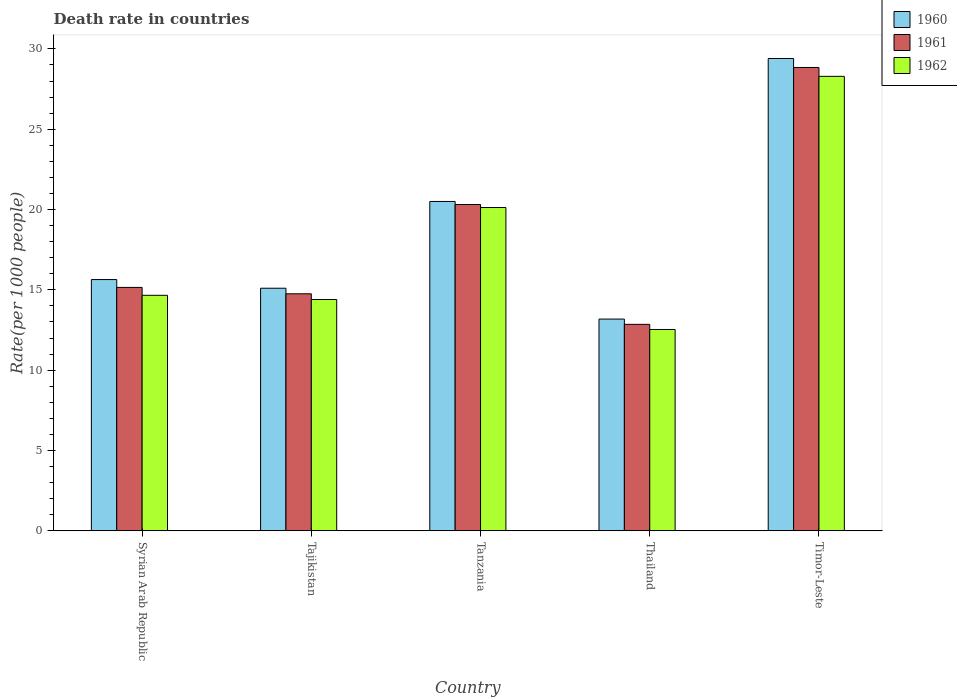How many groups of bars are there?
Provide a succinct answer. 5. Are the number of bars per tick equal to the number of legend labels?
Ensure brevity in your answer.  Yes. Are the number of bars on each tick of the X-axis equal?
Make the answer very short. Yes. How many bars are there on the 5th tick from the left?
Make the answer very short. 3. What is the label of the 2nd group of bars from the left?
Give a very brief answer. Tajikistan. In how many cases, is the number of bars for a given country not equal to the number of legend labels?
Keep it short and to the point. 0. What is the death rate in 1961 in Thailand?
Ensure brevity in your answer.  12.85. Across all countries, what is the maximum death rate in 1962?
Keep it short and to the point. 28.29. Across all countries, what is the minimum death rate in 1960?
Give a very brief answer. 13.18. In which country was the death rate in 1961 maximum?
Provide a short and direct response. Timor-Leste. In which country was the death rate in 1961 minimum?
Offer a very short reply. Thailand. What is the total death rate in 1961 in the graph?
Give a very brief answer. 91.91. What is the difference between the death rate in 1960 in Thailand and that in Timor-Leste?
Your answer should be compact. -16.22. What is the difference between the death rate in 1960 in Syrian Arab Republic and the death rate in 1962 in Thailand?
Provide a succinct answer. 3.11. What is the average death rate in 1961 per country?
Provide a succinct answer. 18.38. What is the difference between the death rate of/in 1962 and death rate of/in 1960 in Tanzania?
Provide a short and direct response. -0.38. In how many countries, is the death rate in 1962 greater than 15?
Ensure brevity in your answer.  2. What is the ratio of the death rate in 1962 in Tajikistan to that in Thailand?
Provide a short and direct response. 1.15. Is the death rate in 1961 in Tajikistan less than that in Timor-Leste?
Make the answer very short. Yes. What is the difference between the highest and the second highest death rate in 1962?
Give a very brief answer. 8.17. What is the difference between the highest and the lowest death rate in 1962?
Provide a short and direct response. 15.76. In how many countries, is the death rate in 1962 greater than the average death rate in 1962 taken over all countries?
Ensure brevity in your answer.  2. Is the sum of the death rate in 1960 in Syrian Arab Republic and Tanzania greater than the maximum death rate in 1962 across all countries?
Your answer should be compact. Yes. What does the 2nd bar from the left in Thailand represents?
Provide a short and direct response. 1961. What does the 3rd bar from the right in Tanzania represents?
Ensure brevity in your answer.  1960. Is it the case that in every country, the sum of the death rate in 1961 and death rate in 1962 is greater than the death rate in 1960?
Provide a succinct answer. Yes. Are all the bars in the graph horizontal?
Your answer should be compact. No. Are the values on the major ticks of Y-axis written in scientific E-notation?
Ensure brevity in your answer.  No. Does the graph contain grids?
Offer a terse response. No. How are the legend labels stacked?
Keep it short and to the point. Vertical. What is the title of the graph?
Keep it short and to the point. Death rate in countries. Does "1975" appear as one of the legend labels in the graph?
Your answer should be very brief. No. What is the label or title of the Y-axis?
Keep it short and to the point. Rate(per 1000 people). What is the Rate(per 1000 people) of 1960 in Syrian Arab Republic?
Make the answer very short. 15.64. What is the Rate(per 1000 people) of 1961 in Syrian Arab Republic?
Your answer should be compact. 15.15. What is the Rate(per 1000 people) of 1962 in Syrian Arab Republic?
Your response must be concise. 14.66. What is the Rate(per 1000 people) of 1960 in Tajikistan?
Provide a short and direct response. 15.1. What is the Rate(per 1000 people) in 1961 in Tajikistan?
Provide a short and direct response. 14.75. What is the Rate(per 1000 people) in 1962 in Tajikistan?
Your answer should be compact. 14.4. What is the Rate(per 1000 people) in 1960 in Tanzania?
Make the answer very short. 20.5. What is the Rate(per 1000 people) of 1961 in Tanzania?
Keep it short and to the point. 20.31. What is the Rate(per 1000 people) of 1962 in Tanzania?
Offer a very short reply. 20.12. What is the Rate(per 1000 people) of 1960 in Thailand?
Offer a terse response. 13.18. What is the Rate(per 1000 people) of 1961 in Thailand?
Give a very brief answer. 12.85. What is the Rate(per 1000 people) in 1962 in Thailand?
Provide a succinct answer. 12.53. What is the Rate(per 1000 people) in 1960 in Timor-Leste?
Your answer should be very brief. 29.4. What is the Rate(per 1000 people) in 1961 in Timor-Leste?
Make the answer very short. 28.84. What is the Rate(per 1000 people) in 1962 in Timor-Leste?
Your answer should be compact. 28.29. Across all countries, what is the maximum Rate(per 1000 people) in 1960?
Ensure brevity in your answer.  29.4. Across all countries, what is the maximum Rate(per 1000 people) of 1961?
Provide a short and direct response. 28.84. Across all countries, what is the maximum Rate(per 1000 people) of 1962?
Provide a succinct answer. 28.29. Across all countries, what is the minimum Rate(per 1000 people) of 1960?
Your answer should be compact. 13.18. Across all countries, what is the minimum Rate(per 1000 people) of 1961?
Make the answer very short. 12.85. Across all countries, what is the minimum Rate(per 1000 people) of 1962?
Your answer should be very brief. 12.53. What is the total Rate(per 1000 people) of 1960 in the graph?
Your answer should be compact. 93.83. What is the total Rate(per 1000 people) of 1961 in the graph?
Give a very brief answer. 91.91. What is the total Rate(per 1000 people) in 1962 in the graph?
Provide a short and direct response. 90.01. What is the difference between the Rate(per 1000 people) in 1960 in Syrian Arab Republic and that in Tajikistan?
Your response must be concise. 0.54. What is the difference between the Rate(per 1000 people) of 1961 in Syrian Arab Republic and that in Tajikistan?
Offer a terse response. 0.4. What is the difference between the Rate(per 1000 people) of 1962 in Syrian Arab Republic and that in Tajikistan?
Your answer should be very brief. 0.26. What is the difference between the Rate(per 1000 people) in 1960 in Syrian Arab Republic and that in Tanzania?
Give a very brief answer. -4.86. What is the difference between the Rate(per 1000 people) in 1961 in Syrian Arab Republic and that in Tanzania?
Offer a terse response. -5.16. What is the difference between the Rate(per 1000 people) in 1962 in Syrian Arab Republic and that in Tanzania?
Your answer should be compact. -5.46. What is the difference between the Rate(per 1000 people) in 1960 in Syrian Arab Republic and that in Thailand?
Make the answer very short. 2.46. What is the difference between the Rate(per 1000 people) in 1961 in Syrian Arab Republic and that in Thailand?
Make the answer very short. 2.3. What is the difference between the Rate(per 1000 people) of 1962 in Syrian Arab Republic and that in Thailand?
Give a very brief answer. 2.13. What is the difference between the Rate(per 1000 people) of 1960 in Syrian Arab Republic and that in Timor-Leste?
Offer a very short reply. -13.76. What is the difference between the Rate(per 1000 people) of 1961 in Syrian Arab Republic and that in Timor-Leste?
Provide a succinct answer. -13.69. What is the difference between the Rate(per 1000 people) in 1962 in Syrian Arab Republic and that in Timor-Leste?
Provide a short and direct response. -13.63. What is the difference between the Rate(per 1000 people) of 1960 in Tajikistan and that in Tanzania?
Make the answer very short. -5.4. What is the difference between the Rate(per 1000 people) in 1961 in Tajikistan and that in Tanzania?
Your response must be concise. -5.56. What is the difference between the Rate(per 1000 people) in 1962 in Tajikistan and that in Tanzania?
Ensure brevity in your answer.  -5.73. What is the difference between the Rate(per 1000 people) in 1960 in Tajikistan and that in Thailand?
Provide a short and direct response. 1.92. What is the difference between the Rate(per 1000 people) of 1961 in Tajikistan and that in Thailand?
Give a very brief answer. 1.9. What is the difference between the Rate(per 1000 people) in 1962 in Tajikistan and that in Thailand?
Provide a short and direct response. 1.87. What is the difference between the Rate(per 1000 people) in 1960 in Tajikistan and that in Timor-Leste?
Offer a very short reply. -14.3. What is the difference between the Rate(per 1000 people) in 1961 in Tajikistan and that in Timor-Leste?
Make the answer very short. -14.09. What is the difference between the Rate(per 1000 people) in 1962 in Tajikistan and that in Timor-Leste?
Keep it short and to the point. -13.89. What is the difference between the Rate(per 1000 people) in 1960 in Tanzania and that in Thailand?
Offer a very short reply. 7.32. What is the difference between the Rate(per 1000 people) of 1961 in Tanzania and that in Thailand?
Your answer should be very brief. 7.46. What is the difference between the Rate(per 1000 people) of 1962 in Tanzania and that in Thailand?
Keep it short and to the point. 7.59. What is the difference between the Rate(per 1000 people) in 1960 in Tanzania and that in Timor-Leste?
Give a very brief answer. -8.9. What is the difference between the Rate(per 1000 people) of 1961 in Tanzania and that in Timor-Leste?
Your answer should be compact. -8.53. What is the difference between the Rate(per 1000 people) of 1962 in Tanzania and that in Timor-Leste?
Ensure brevity in your answer.  -8.17. What is the difference between the Rate(per 1000 people) of 1960 in Thailand and that in Timor-Leste?
Your answer should be very brief. -16.22. What is the difference between the Rate(per 1000 people) in 1961 in Thailand and that in Timor-Leste?
Offer a very short reply. -15.99. What is the difference between the Rate(per 1000 people) in 1962 in Thailand and that in Timor-Leste?
Make the answer very short. -15.76. What is the difference between the Rate(per 1000 people) of 1960 in Syrian Arab Republic and the Rate(per 1000 people) of 1961 in Tajikistan?
Provide a succinct answer. 0.89. What is the difference between the Rate(per 1000 people) of 1960 in Syrian Arab Republic and the Rate(per 1000 people) of 1962 in Tajikistan?
Make the answer very short. 1.24. What is the difference between the Rate(per 1000 people) in 1961 in Syrian Arab Republic and the Rate(per 1000 people) in 1962 in Tajikistan?
Offer a very short reply. 0.75. What is the difference between the Rate(per 1000 people) in 1960 in Syrian Arab Republic and the Rate(per 1000 people) in 1961 in Tanzania?
Make the answer very short. -4.67. What is the difference between the Rate(per 1000 people) in 1960 in Syrian Arab Republic and the Rate(per 1000 people) in 1962 in Tanzania?
Your answer should be compact. -4.48. What is the difference between the Rate(per 1000 people) of 1961 in Syrian Arab Republic and the Rate(per 1000 people) of 1962 in Tanzania?
Keep it short and to the point. -4.97. What is the difference between the Rate(per 1000 people) of 1960 in Syrian Arab Republic and the Rate(per 1000 people) of 1961 in Thailand?
Ensure brevity in your answer.  2.79. What is the difference between the Rate(per 1000 people) of 1960 in Syrian Arab Republic and the Rate(per 1000 people) of 1962 in Thailand?
Provide a short and direct response. 3.11. What is the difference between the Rate(per 1000 people) in 1961 in Syrian Arab Republic and the Rate(per 1000 people) in 1962 in Thailand?
Your response must be concise. 2.62. What is the difference between the Rate(per 1000 people) of 1960 in Syrian Arab Republic and the Rate(per 1000 people) of 1961 in Timor-Leste?
Keep it short and to the point. -13.2. What is the difference between the Rate(per 1000 people) in 1960 in Syrian Arab Republic and the Rate(per 1000 people) in 1962 in Timor-Leste?
Give a very brief answer. -12.65. What is the difference between the Rate(per 1000 people) of 1961 in Syrian Arab Republic and the Rate(per 1000 people) of 1962 in Timor-Leste?
Offer a terse response. -13.14. What is the difference between the Rate(per 1000 people) of 1960 in Tajikistan and the Rate(per 1000 people) of 1961 in Tanzania?
Provide a short and direct response. -5.21. What is the difference between the Rate(per 1000 people) of 1960 in Tajikistan and the Rate(per 1000 people) of 1962 in Tanzania?
Provide a short and direct response. -5.02. What is the difference between the Rate(per 1000 people) in 1961 in Tajikistan and the Rate(per 1000 people) in 1962 in Tanzania?
Your answer should be very brief. -5.37. What is the difference between the Rate(per 1000 people) in 1960 in Tajikistan and the Rate(per 1000 people) in 1961 in Thailand?
Provide a succinct answer. 2.25. What is the difference between the Rate(per 1000 people) in 1960 in Tajikistan and the Rate(per 1000 people) in 1962 in Thailand?
Give a very brief answer. 2.57. What is the difference between the Rate(per 1000 people) of 1961 in Tajikistan and the Rate(per 1000 people) of 1962 in Thailand?
Your answer should be compact. 2.22. What is the difference between the Rate(per 1000 people) of 1960 in Tajikistan and the Rate(per 1000 people) of 1961 in Timor-Leste?
Provide a succinct answer. -13.74. What is the difference between the Rate(per 1000 people) of 1960 in Tajikistan and the Rate(per 1000 people) of 1962 in Timor-Leste?
Keep it short and to the point. -13.19. What is the difference between the Rate(per 1000 people) of 1961 in Tajikistan and the Rate(per 1000 people) of 1962 in Timor-Leste?
Ensure brevity in your answer.  -13.54. What is the difference between the Rate(per 1000 people) of 1960 in Tanzania and the Rate(per 1000 people) of 1961 in Thailand?
Offer a very short reply. 7.65. What is the difference between the Rate(per 1000 people) in 1960 in Tanzania and the Rate(per 1000 people) in 1962 in Thailand?
Offer a terse response. 7.97. What is the difference between the Rate(per 1000 people) in 1961 in Tanzania and the Rate(per 1000 people) in 1962 in Thailand?
Give a very brief answer. 7.78. What is the difference between the Rate(per 1000 people) in 1960 in Tanzania and the Rate(per 1000 people) in 1961 in Timor-Leste?
Your answer should be very brief. -8.34. What is the difference between the Rate(per 1000 people) in 1960 in Tanzania and the Rate(per 1000 people) in 1962 in Timor-Leste?
Offer a terse response. -7.79. What is the difference between the Rate(per 1000 people) in 1961 in Tanzania and the Rate(per 1000 people) in 1962 in Timor-Leste?
Your answer should be very brief. -7.98. What is the difference between the Rate(per 1000 people) in 1960 in Thailand and the Rate(per 1000 people) in 1961 in Timor-Leste?
Your response must be concise. -15.66. What is the difference between the Rate(per 1000 people) of 1960 in Thailand and the Rate(per 1000 people) of 1962 in Timor-Leste?
Provide a short and direct response. -15.11. What is the difference between the Rate(per 1000 people) in 1961 in Thailand and the Rate(per 1000 people) in 1962 in Timor-Leste?
Your response must be concise. -15.44. What is the average Rate(per 1000 people) of 1960 per country?
Ensure brevity in your answer.  18.77. What is the average Rate(per 1000 people) of 1961 per country?
Ensure brevity in your answer.  18.38. What is the average Rate(per 1000 people) of 1962 per country?
Offer a terse response. 18. What is the difference between the Rate(per 1000 people) of 1960 and Rate(per 1000 people) of 1961 in Syrian Arab Republic?
Provide a short and direct response. 0.49. What is the difference between the Rate(per 1000 people) of 1961 and Rate(per 1000 people) of 1962 in Syrian Arab Republic?
Make the answer very short. 0.49. What is the difference between the Rate(per 1000 people) in 1960 and Rate(per 1000 people) in 1961 in Tajikistan?
Keep it short and to the point. 0.35. What is the difference between the Rate(per 1000 people) of 1960 and Rate(per 1000 people) of 1962 in Tajikistan?
Offer a terse response. 0.7. What is the difference between the Rate(per 1000 people) in 1961 and Rate(per 1000 people) in 1962 in Tajikistan?
Give a very brief answer. 0.35. What is the difference between the Rate(per 1000 people) of 1960 and Rate(per 1000 people) of 1961 in Tanzania?
Make the answer very short. 0.19. What is the difference between the Rate(per 1000 people) of 1960 and Rate(per 1000 people) of 1962 in Tanzania?
Make the answer very short. 0.38. What is the difference between the Rate(per 1000 people) of 1961 and Rate(per 1000 people) of 1962 in Tanzania?
Provide a short and direct response. 0.19. What is the difference between the Rate(per 1000 people) in 1960 and Rate(per 1000 people) in 1961 in Thailand?
Provide a succinct answer. 0.33. What is the difference between the Rate(per 1000 people) of 1960 and Rate(per 1000 people) of 1962 in Thailand?
Provide a succinct answer. 0.65. What is the difference between the Rate(per 1000 people) of 1961 and Rate(per 1000 people) of 1962 in Thailand?
Provide a short and direct response. 0.32. What is the difference between the Rate(per 1000 people) in 1960 and Rate(per 1000 people) in 1961 in Timor-Leste?
Make the answer very short. 0.56. What is the difference between the Rate(per 1000 people) in 1960 and Rate(per 1000 people) in 1962 in Timor-Leste?
Give a very brief answer. 1.11. What is the difference between the Rate(per 1000 people) in 1961 and Rate(per 1000 people) in 1962 in Timor-Leste?
Offer a very short reply. 0.55. What is the ratio of the Rate(per 1000 people) in 1960 in Syrian Arab Republic to that in Tajikistan?
Make the answer very short. 1.04. What is the ratio of the Rate(per 1000 people) of 1961 in Syrian Arab Republic to that in Tajikistan?
Make the answer very short. 1.03. What is the ratio of the Rate(per 1000 people) in 1962 in Syrian Arab Republic to that in Tajikistan?
Ensure brevity in your answer.  1.02. What is the ratio of the Rate(per 1000 people) in 1960 in Syrian Arab Republic to that in Tanzania?
Your answer should be very brief. 0.76. What is the ratio of the Rate(per 1000 people) in 1961 in Syrian Arab Republic to that in Tanzania?
Offer a very short reply. 0.75. What is the ratio of the Rate(per 1000 people) in 1962 in Syrian Arab Republic to that in Tanzania?
Your response must be concise. 0.73. What is the ratio of the Rate(per 1000 people) in 1960 in Syrian Arab Republic to that in Thailand?
Make the answer very short. 1.19. What is the ratio of the Rate(per 1000 people) in 1961 in Syrian Arab Republic to that in Thailand?
Provide a succinct answer. 1.18. What is the ratio of the Rate(per 1000 people) in 1962 in Syrian Arab Republic to that in Thailand?
Your answer should be very brief. 1.17. What is the ratio of the Rate(per 1000 people) in 1960 in Syrian Arab Republic to that in Timor-Leste?
Keep it short and to the point. 0.53. What is the ratio of the Rate(per 1000 people) of 1961 in Syrian Arab Republic to that in Timor-Leste?
Provide a succinct answer. 0.53. What is the ratio of the Rate(per 1000 people) of 1962 in Syrian Arab Republic to that in Timor-Leste?
Your answer should be very brief. 0.52. What is the ratio of the Rate(per 1000 people) of 1960 in Tajikistan to that in Tanzania?
Provide a short and direct response. 0.74. What is the ratio of the Rate(per 1000 people) of 1961 in Tajikistan to that in Tanzania?
Your answer should be compact. 0.73. What is the ratio of the Rate(per 1000 people) in 1962 in Tajikistan to that in Tanzania?
Offer a very short reply. 0.72. What is the ratio of the Rate(per 1000 people) of 1960 in Tajikistan to that in Thailand?
Your answer should be very brief. 1.15. What is the ratio of the Rate(per 1000 people) of 1961 in Tajikistan to that in Thailand?
Offer a very short reply. 1.15. What is the ratio of the Rate(per 1000 people) of 1962 in Tajikistan to that in Thailand?
Keep it short and to the point. 1.15. What is the ratio of the Rate(per 1000 people) in 1960 in Tajikistan to that in Timor-Leste?
Keep it short and to the point. 0.51. What is the ratio of the Rate(per 1000 people) of 1961 in Tajikistan to that in Timor-Leste?
Offer a terse response. 0.51. What is the ratio of the Rate(per 1000 people) of 1962 in Tajikistan to that in Timor-Leste?
Your answer should be compact. 0.51. What is the ratio of the Rate(per 1000 people) in 1960 in Tanzania to that in Thailand?
Provide a succinct answer. 1.56. What is the ratio of the Rate(per 1000 people) in 1961 in Tanzania to that in Thailand?
Offer a terse response. 1.58. What is the ratio of the Rate(per 1000 people) of 1962 in Tanzania to that in Thailand?
Your answer should be compact. 1.61. What is the ratio of the Rate(per 1000 people) in 1960 in Tanzania to that in Timor-Leste?
Offer a terse response. 0.7. What is the ratio of the Rate(per 1000 people) of 1961 in Tanzania to that in Timor-Leste?
Make the answer very short. 0.7. What is the ratio of the Rate(per 1000 people) in 1962 in Tanzania to that in Timor-Leste?
Your response must be concise. 0.71. What is the ratio of the Rate(per 1000 people) of 1960 in Thailand to that in Timor-Leste?
Your answer should be compact. 0.45. What is the ratio of the Rate(per 1000 people) of 1961 in Thailand to that in Timor-Leste?
Give a very brief answer. 0.45. What is the ratio of the Rate(per 1000 people) in 1962 in Thailand to that in Timor-Leste?
Your answer should be very brief. 0.44. What is the difference between the highest and the second highest Rate(per 1000 people) of 1960?
Ensure brevity in your answer.  8.9. What is the difference between the highest and the second highest Rate(per 1000 people) in 1961?
Provide a succinct answer. 8.53. What is the difference between the highest and the second highest Rate(per 1000 people) in 1962?
Provide a succinct answer. 8.17. What is the difference between the highest and the lowest Rate(per 1000 people) of 1960?
Provide a succinct answer. 16.22. What is the difference between the highest and the lowest Rate(per 1000 people) of 1961?
Your response must be concise. 15.99. What is the difference between the highest and the lowest Rate(per 1000 people) of 1962?
Your answer should be compact. 15.76. 